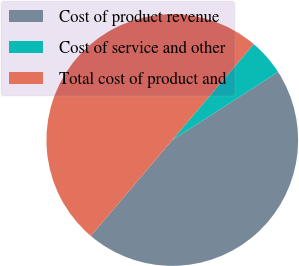<chart> <loc_0><loc_0><loc_500><loc_500><pie_chart><fcel>Cost of product revenue<fcel>Cost of service and other<fcel>Total cost of product and<nl><fcel>45.3%<fcel>4.7%<fcel>50.0%<nl></chart> 